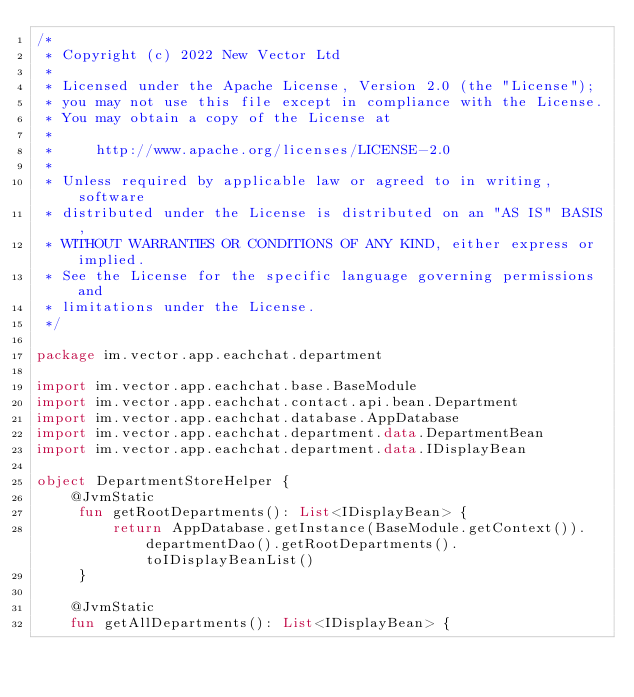Convert code to text. <code><loc_0><loc_0><loc_500><loc_500><_Kotlin_>/*
 * Copyright (c) 2022 New Vector Ltd
 *
 * Licensed under the Apache License, Version 2.0 (the "License");
 * you may not use this file except in compliance with the License.
 * You may obtain a copy of the License at
 *
 *     http://www.apache.org/licenses/LICENSE-2.0
 *
 * Unless required by applicable law or agreed to in writing, software
 * distributed under the License is distributed on an "AS IS" BASIS,
 * WITHOUT WARRANTIES OR CONDITIONS OF ANY KIND, either express or implied.
 * See the License for the specific language governing permissions and
 * limitations under the License.
 */

package im.vector.app.eachchat.department

import im.vector.app.eachchat.base.BaseModule
import im.vector.app.eachchat.contact.api.bean.Department
import im.vector.app.eachchat.database.AppDatabase
import im.vector.app.eachchat.department.data.DepartmentBean
import im.vector.app.eachchat.department.data.IDisplayBean

object DepartmentStoreHelper {
    @JvmStatic
     fun getRootDepartments(): List<IDisplayBean> {
         return AppDatabase.getInstance(BaseModule.getContext()).departmentDao().getRootDepartments().toIDisplayBeanList()
     }

    @JvmStatic
    fun getAllDepartments(): List<IDisplayBean> {</code> 